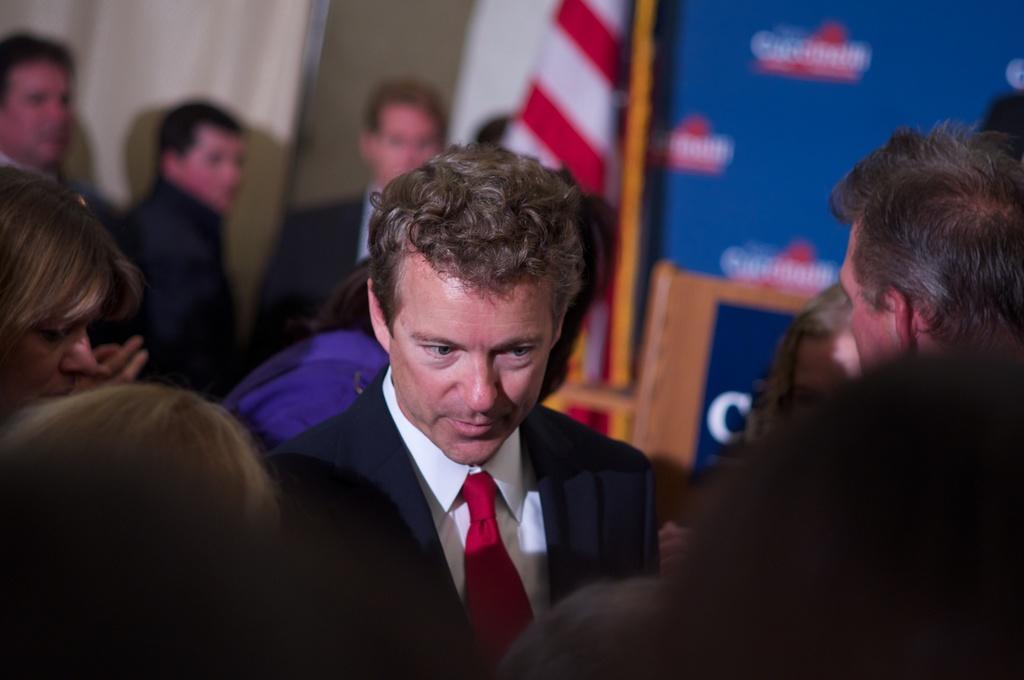How would you summarize this image in a sentence or two? In the center of the image a group of people are there. In the background of the image we can see wall, flag, boards are there. 